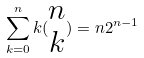<formula> <loc_0><loc_0><loc_500><loc_500>\sum _ { k = 0 } ^ { n } k ( \begin{matrix} n \\ k \end{matrix} ) = n 2 ^ { n - 1 }</formula> 